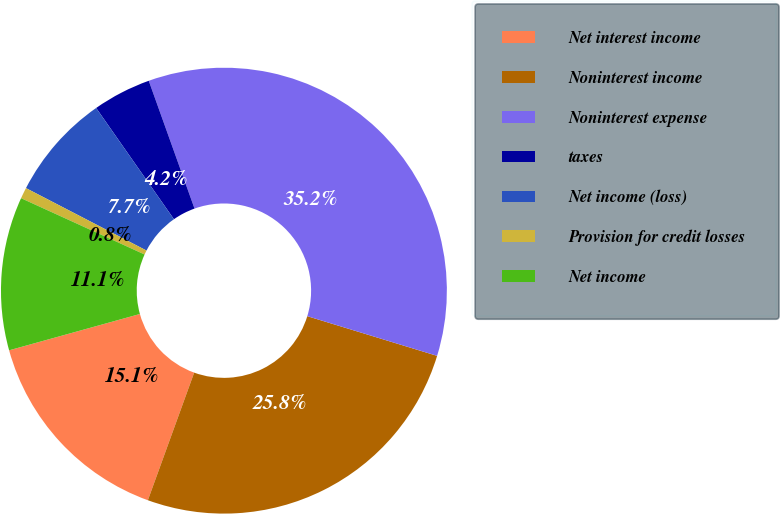Convert chart. <chart><loc_0><loc_0><loc_500><loc_500><pie_chart><fcel>Net interest income<fcel>Noninterest income<fcel>Noninterest expense<fcel>taxes<fcel>Net income (loss)<fcel>Provision for credit losses<fcel>Net income<nl><fcel>15.15%<fcel>25.82%<fcel>35.2%<fcel>4.24%<fcel>7.68%<fcel>0.8%<fcel>11.12%<nl></chart> 